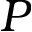Convert formula to latex. <formula><loc_0><loc_0><loc_500><loc_500>P</formula> 